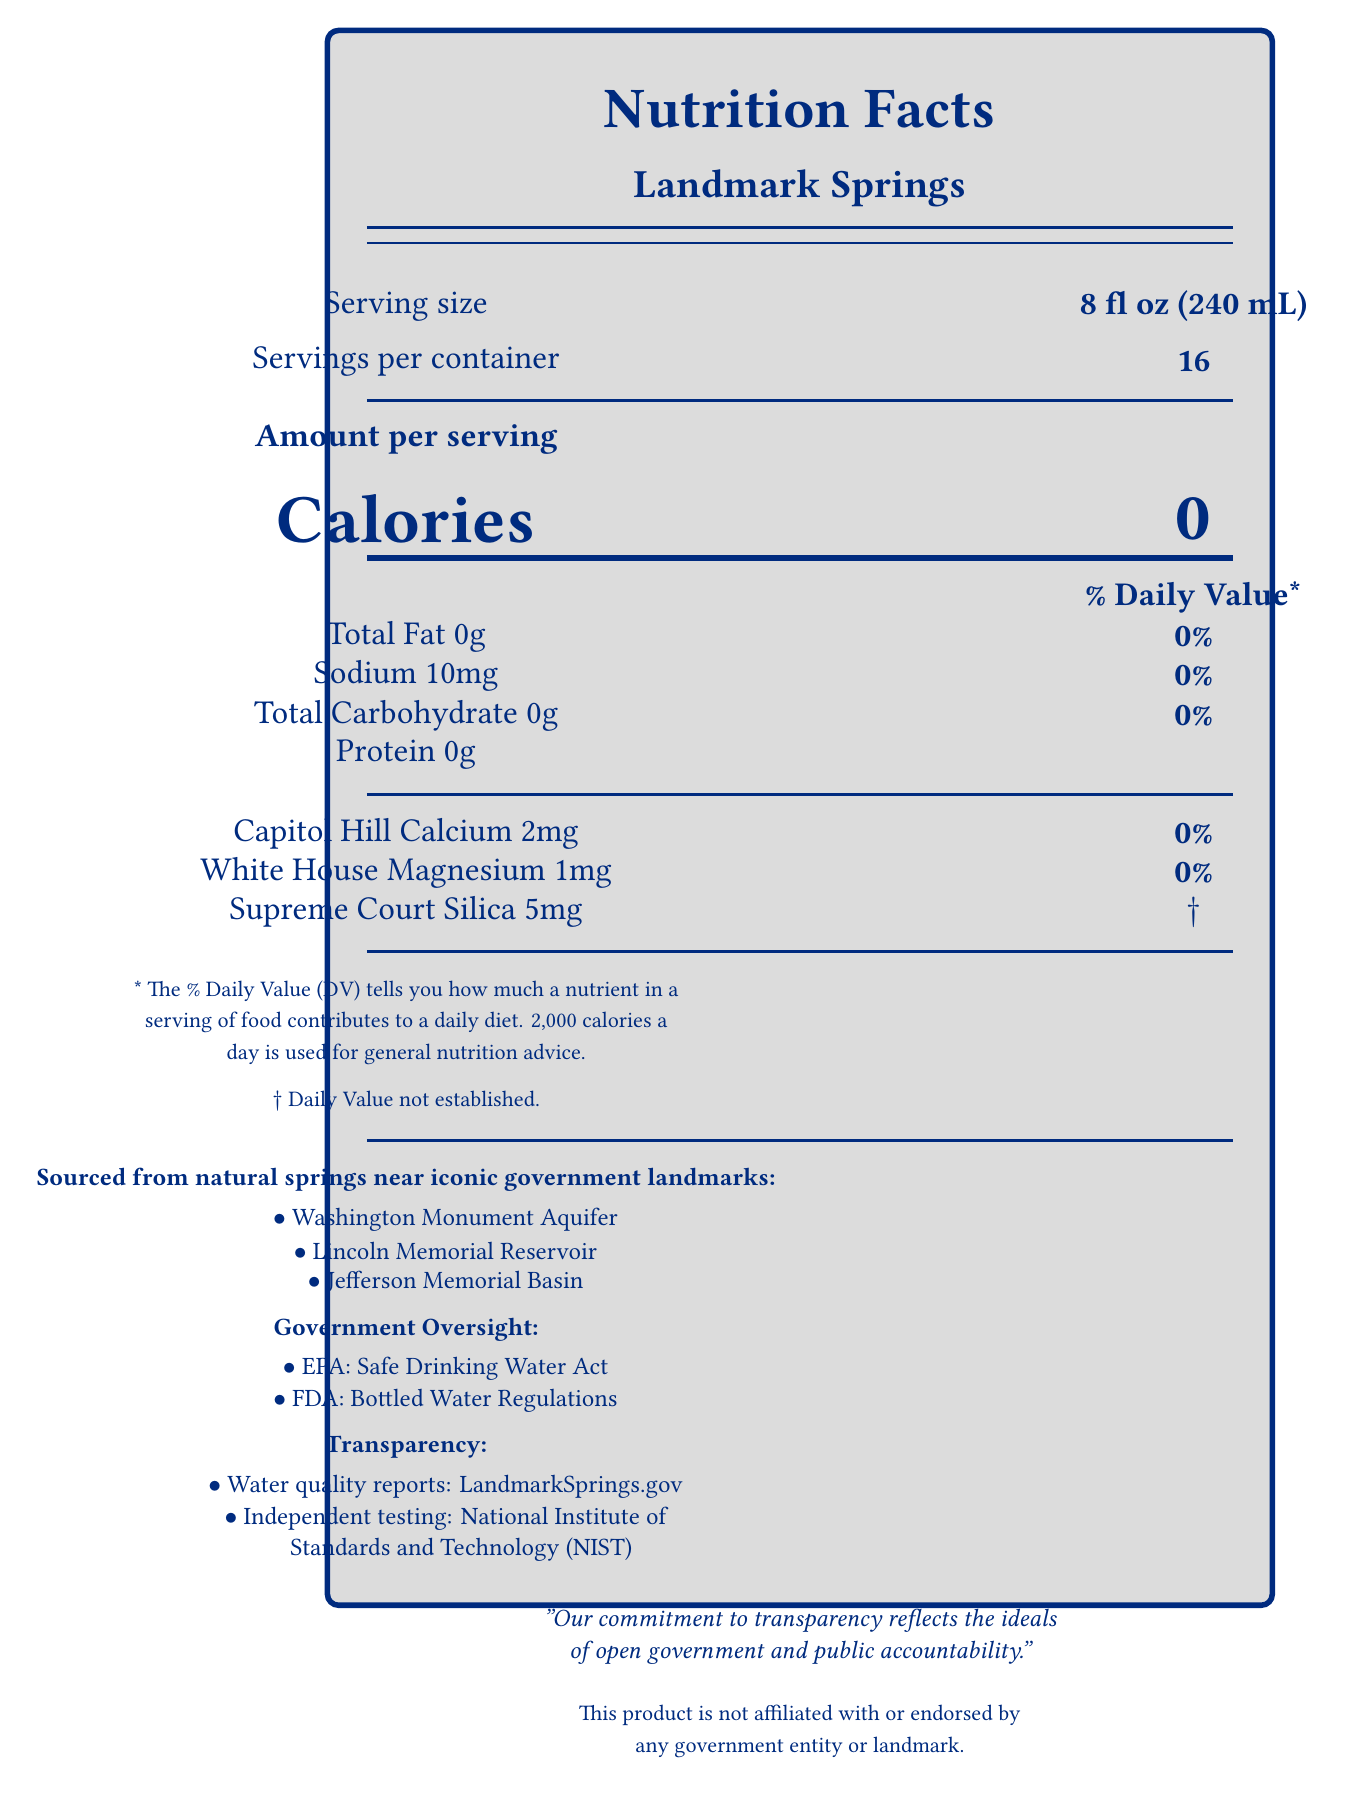what is the serving size? The serving size is listed at the top left of the document.
Answer: 8 fl oz (240 mL) how many servings are in the container? The servings per container is listed directly below the serving size.
Answer: 16 what are the calories per serving? The calorie count is prominently displayed in the middle section of the document.
Answer: 0 what is the amount of sodium in a serving? The sodium content is located in the section beneath the calories, listed as 10mg.
Answer: 10mg which mineral has a daily value that is not established? The silica, listed as "Supreme Court Silica," has a footnote indicating that its daily value is not established (†).
Answer: Supreme Court Silica what is the source statement for this bottled water? The source statement is listed under the minerals section, stating that it is sourced from natural springs near iconic government landmarks.
Answer: Sourced from natural springs near iconic government landmarks: list the government agencies overseeing the regulations for this bottled water. The government oversight section lists the EPA and FDA and their respective regulations.
Answer: Environmental Protection Agency (EPA) and Food and Drug Administration (FDA) which landmark sources does the bottled water claim to come from? A. The White House B. Jefferson Memorial Basin C. Golden Gate Bridge D. Lincoln Memorial Reservoir Jefferson Memorial Basin and Lincoln Memorial Reservoir are listed under the landmark sources section.
Answer: B and D how can consumers access water quality reports? A. By visiting LandmarkSprings.com B. By checking LandmarkSprings.org C. By visiting LandmarkSprings.gov D. By calling a toll-free number The document states that water quality reports are available at LandmarkSprings.gov.
Answer: C does the product have any affiliation with government entities or landmarks? The disclaimer at the bottom of the document explicitly states that the product is not affiliated with or endorsed by any government entity or landmark.
Answer: No does the product contain any protein? The protein content is listed as 0g in the document.
Answer: No what is the main idea conveyed by this document? The document is a nutrition facts label for Landmark Springs bottled water. It lists the nutritional information, details the minerals present, mentions the water's sources, oversight by government agencies, and highlights the company's commitment to transparency.
Answer: The document provides the nutritional facts for Landmark Springs bottled water, details its mineral content, sources from iconic government landmarks, lists the overseeing government agencies, and emphasizes the company’s commitment to transparency and public accountability. what is the pH level of the bottled water in the document? The document does not provide any information about the pH level of the bottled water.
Answer: Not enough information 